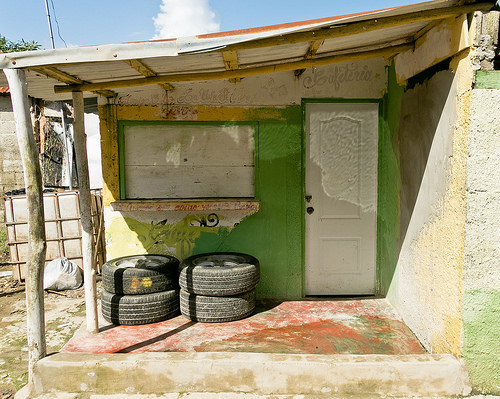<image>
Is there a tire on the wall? Yes. Looking at the image, I can see the tire is positioned on top of the wall, with the wall providing support. 